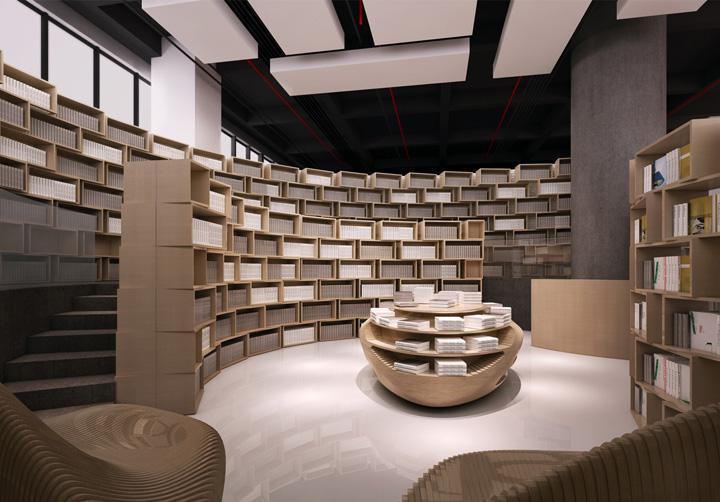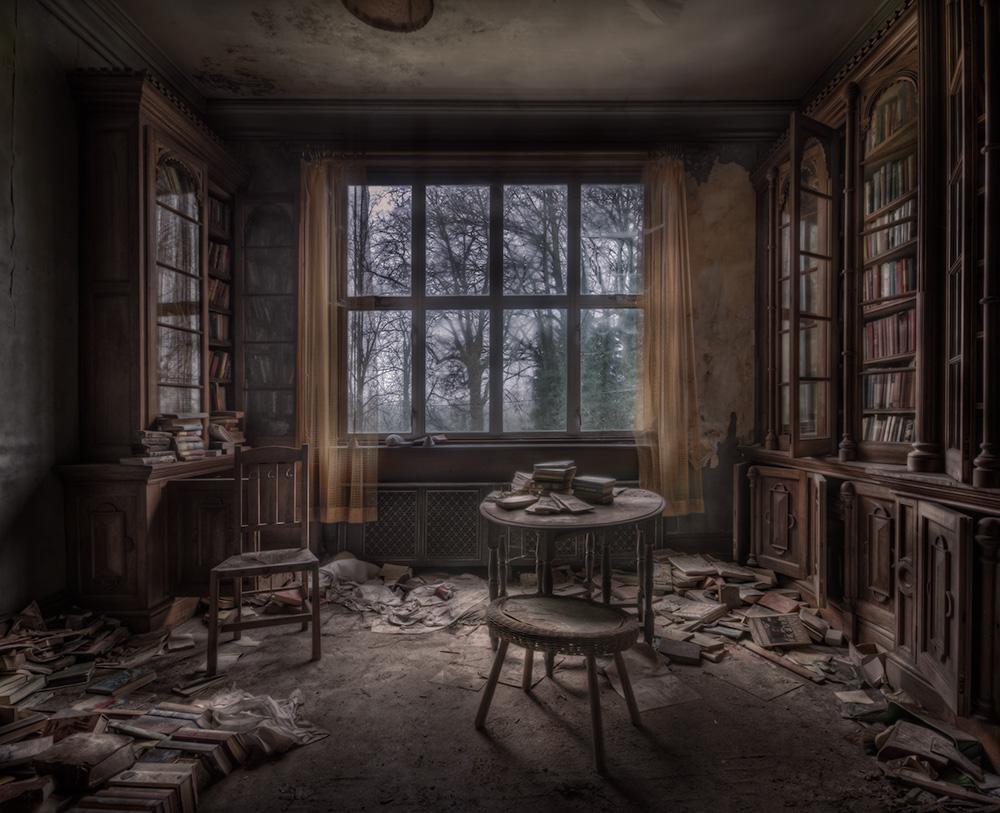The first image is the image on the left, the second image is the image on the right. Evaluate the accuracy of this statement regarding the images: "An interior features bookshelves under at least one arch shape at the back, and upholstered furniture in front.". Is it true? Answer yes or no. No. The first image is the image on the left, the second image is the image on the right. For the images displayed, is the sentence "In at least one image there at least two bookshelves with one window in between them." factually correct? Answer yes or no. Yes. 